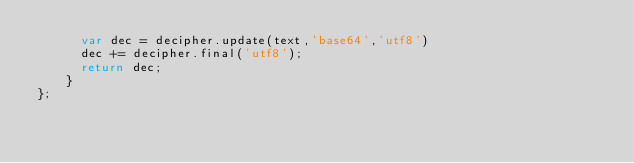<code> <loc_0><loc_0><loc_500><loc_500><_JavaScript_>	  var dec = decipher.update(text,'base64','utf8')
	  dec += decipher.final('utf8');
	  return dec;
	}
};</code> 